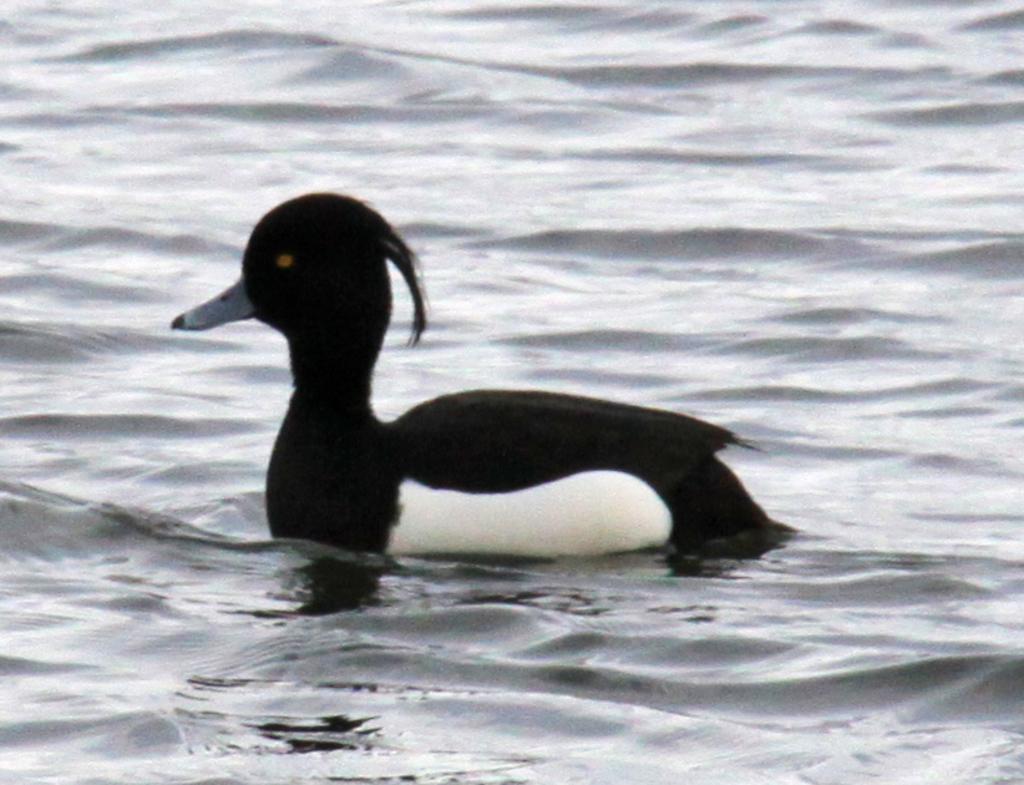Describe this image in one or two sentences. In this picture there is a Hooded merganser which is in black and white color is on the water. 